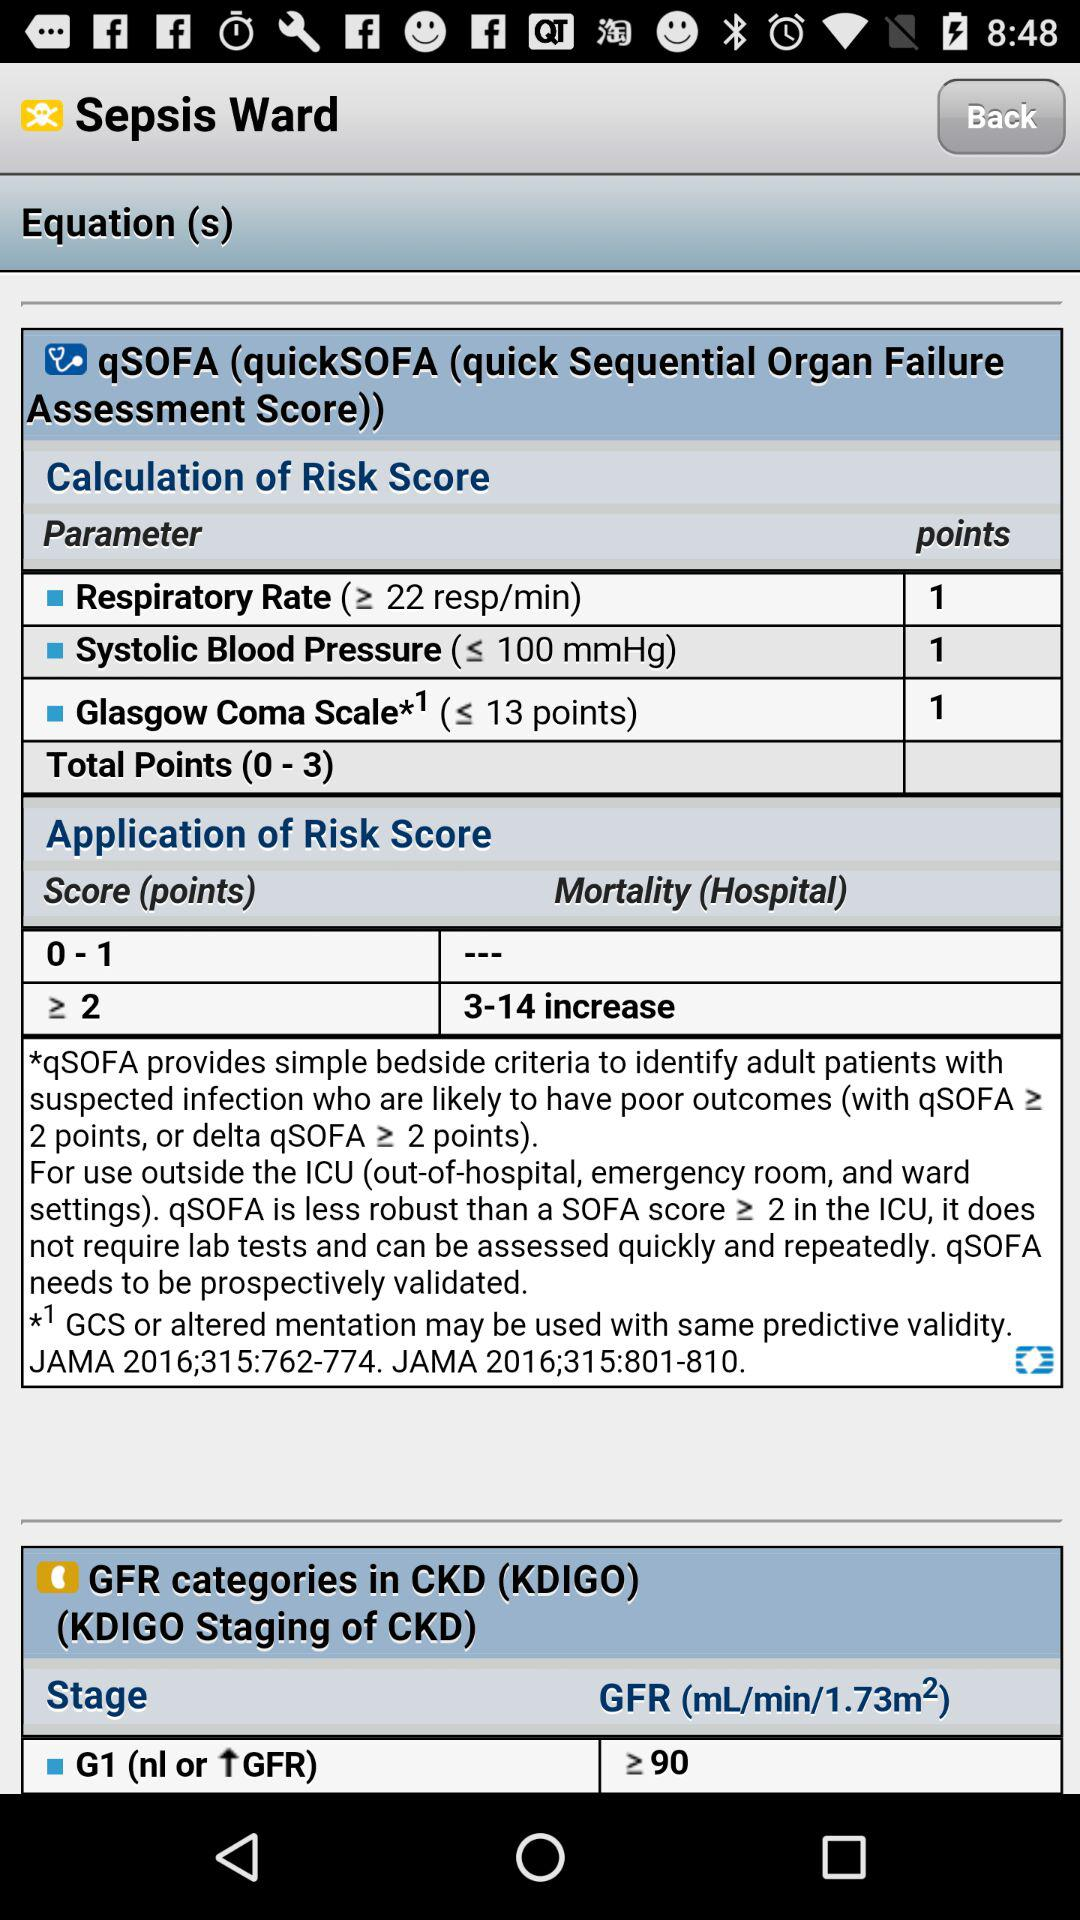How many total points are shown here? The total points are 0-3. 